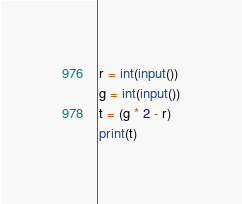<code> <loc_0><loc_0><loc_500><loc_500><_Python_>r = int(input())
g = int(input())
t = (g * 2 - r)
print(t)</code> 